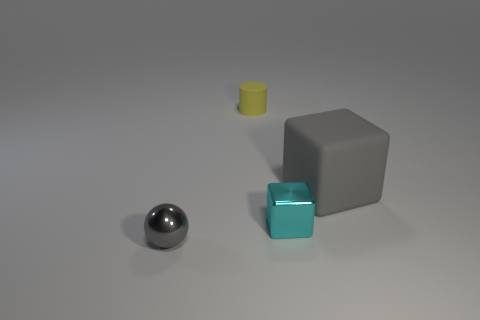Add 3 cyan metallic cubes. How many objects exist? 7 Subtract all cylinders. How many objects are left? 3 Subtract 0 yellow blocks. How many objects are left? 4 Subtract all tiny cylinders. Subtract all metal cubes. How many objects are left? 2 Add 4 matte cubes. How many matte cubes are left? 5 Add 2 brown metal things. How many brown metal things exist? 2 